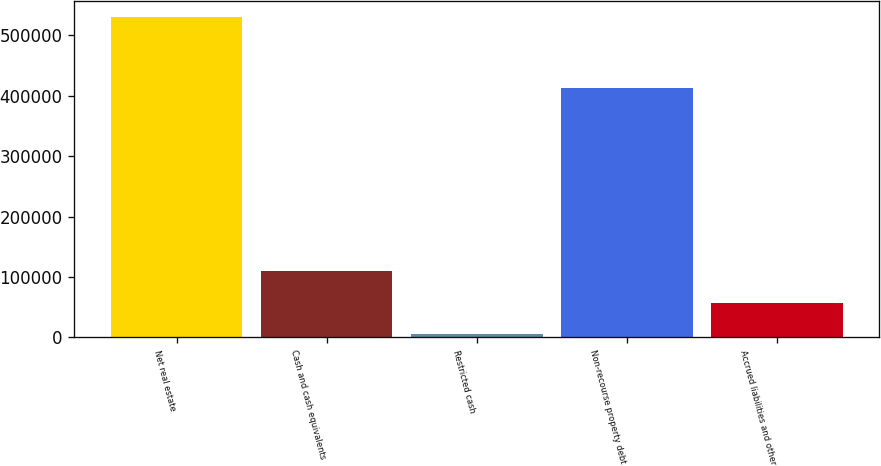<chart> <loc_0><loc_0><loc_500><loc_500><bar_chart><fcel>Net real estate<fcel>Cash and cash equivalents<fcel>Restricted cash<fcel>Non-recourse property debt<fcel>Accrued liabilities and other<nl><fcel>529898<fcel>109818<fcel>4798<fcel>412205<fcel>57308<nl></chart> 